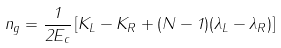<formula> <loc_0><loc_0><loc_500><loc_500>n _ { g } = \frac { 1 } { 2 E _ { c } } \left [ K _ { L } - K _ { R } + ( N - 1 ) ( \lambda _ { L } - \lambda _ { R } ) \right ]</formula> 